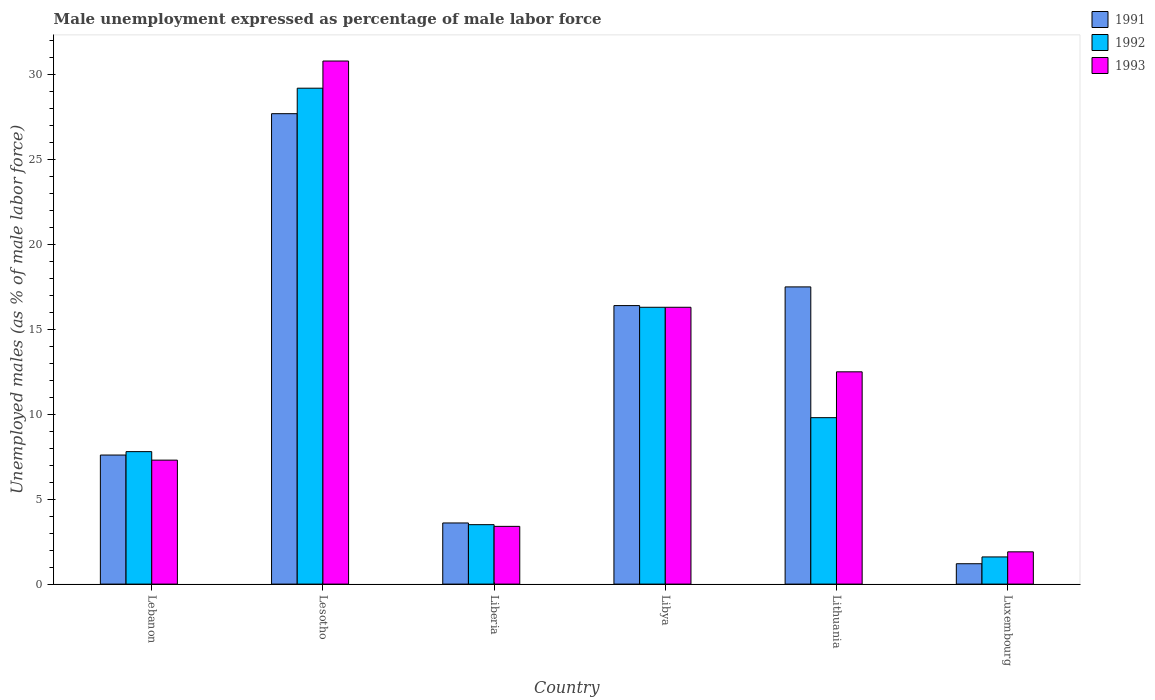How many different coloured bars are there?
Keep it short and to the point. 3. Are the number of bars per tick equal to the number of legend labels?
Ensure brevity in your answer.  Yes. Are the number of bars on each tick of the X-axis equal?
Provide a short and direct response. Yes. What is the label of the 2nd group of bars from the left?
Keep it short and to the point. Lesotho. In how many cases, is the number of bars for a given country not equal to the number of legend labels?
Offer a terse response. 0. What is the unemployment in males in in 1991 in Lebanon?
Your response must be concise. 7.6. Across all countries, what is the maximum unemployment in males in in 1993?
Offer a very short reply. 30.8. Across all countries, what is the minimum unemployment in males in in 1991?
Ensure brevity in your answer.  1.2. In which country was the unemployment in males in in 1993 maximum?
Your response must be concise. Lesotho. In which country was the unemployment in males in in 1992 minimum?
Provide a short and direct response. Luxembourg. What is the total unemployment in males in in 1992 in the graph?
Give a very brief answer. 68.2. What is the difference between the unemployment in males in in 1992 in Lithuania and that in Luxembourg?
Ensure brevity in your answer.  8.2. What is the difference between the unemployment in males in in 1991 in Luxembourg and the unemployment in males in in 1992 in Lebanon?
Offer a terse response. -6.6. What is the average unemployment in males in in 1992 per country?
Your response must be concise. 11.37. What is the difference between the unemployment in males in of/in 1993 and unemployment in males in of/in 1991 in Lebanon?
Your response must be concise. -0.3. In how many countries, is the unemployment in males in in 1992 greater than 24 %?
Your answer should be compact. 1. What is the ratio of the unemployment in males in in 1991 in Lesotho to that in Luxembourg?
Offer a very short reply. 23.08. Is the unemployment in males in in 1993 in Lesotho less than that in Liberia?
Your answer should be compact. No. What is the difference between the highest and the second highest unemployment in males in in 1992?
Offer a terse response. 6.5. What is the difference between the highest and the lowest unemployment in males in in 1991?
Give a very brief answer. 26.5. In how many countries, is the unemployment in males in in 1991 greater than the average unemployment in males in in 1991 taken over all countries?
Offer a very short reply. 3. What is the difference between two consecutive major ticks on the Y-axis?
Offer a very short reply. 5. Are the values on the major ticks of Y-axis written in scientific E-notation?
Your response must be concise. No. Does the graph contain any zero values?
Offer a terse response. No. Does the graph contain grids?
Give a very brief answer. No. How many legend labels are there?
Provide a short and direct response. 3. What is the title of the graph?
Offer a very short reply. Male unemployment expressed as percentage of male labor force. What is the label or title of the Y-axis?
Your response must be concise. Unemployed males (as % of male labor force). What is the Unemployed males (as % of male labor force) of 1991 in Lebanon?
Offer a terse response. 7.6. What is the Unemployed males (as % of male labor force) of 1992 in Lebanon?
Offer a very short reply. 7.8. What is the Unemployed males (as % of male labor force) in 1993 in Lebanon?
Your response must be concise. 7.3. What is the Unemployed males (as % of male labor force) of 1991 in Lesotho?
Make the answer very short. 27.7. What is the Unemployed males (as % of male labor force) of 1992 in Lesotho?
Offer a very short reply. 29.2. What is the Unemployed males (as % of male labor force) in 1993 in Lesotho?
Your answer should be very brief. 30.8. What is the Unemployed males (as % of male labor force) of 1991 in Liberia?
Your answer should be very brief. 3.6. What is the Unemployed males (as % of male labor force) of 1993 in Liberia?
Ensure brevity in your answer.  3.4. What is the Unemployed males (as % of male labor force) in 1991 in Libya?
Your answer should be very brief. 16.4. What is the Unemployed males (as % of male labor force) in 1992 in Libya?
Your answer should be very brief. 16.3. What is the Unemployed males (as % of male labor force) in 1993 in Libya?
Provide a succinct answer. 16.3. What is the Unemployed males (as % of male labor force) of 1992 in Lithuania?
Your answer should be compact. 9.8. What is the Unemployed males (as % of male labor force) of 1991 in Luxembourg?
Keep it short and to the point. 1.2. What is the Unemployed males (as % of male labor force) in 1992 in Luxembourg?
Your response must be concise. 1.6. What is the Unemployed males (as % of male labor force) of 1993 in Luxembourg?
Ensure brevity in your answer.  1.9. Across all countries, what is the maximum Unemployed males (as % of male labor force) of 1991?
Your answer should be compact. 27.7. Across all countries, what is the maximum Unemployed males (as % of male labor force) in 1992?
Provide a succinct answer. 29.2. Across all countries, what is the maximum Unemployed males (as % of male labor force) of 1993?
Keep it short and to the point. 30.8. Across all countries, what is the minimum Unemployed males (as % of male labor force) in 1991?
Your response must be concise. 1.2. Across all countries, what is the minimum Unemployed males (as % of male labor force) of 1992?
Ensure brevity in your answer.  1.6. Across all countries, what is the minimum Unemployed males (as % of male labor force) in 1993?
Your answer should be very brief. 1.9. What is the total Unemployed males (as % of male labor force) in 1992 in the graph?
Make the answer very short. 68.2. What is the total Unemployed males (as % of male labor force) of 1993 in the graph?
Your answer should be compact. 72.2. What is the difference between the Unemployed males (as % of male labor force) of 1991 in Lebanon and that in Lesotho?
Make the answer very short. -20.1. What is the difference between the Unemployed males (as % of male labor force) of 1992 in Lebanon and that in Lesotho?
Make the answer very short. -21.4. What is the difference between the Unemployed males (as % of male labor force) in 1993 in Lebanon and that in Lesotho?
Your answer should be very brief. -23.5. What is the difference between the Unemployed males (as % of male labor force) of 1991 in Lebanon and that in Liberia?
Your answer should be compact. 4. What is the difference between the Unemployed males (as % of male labor force) of 1992 in Lebanon and that in Liberia?
Your response must be concise. 4.3. What is the difference between the Unemployed males (as % of male labor force) of 1993 in Lebanon and that in Liberia?
Offer a very short reply. 3.9. What is the difference between the Unemployed males (as % of male labor force) in 1993 in Lebanon and that in Libya?
Provide a short and direct response. -9. What is the difference between the Unemployed males (as % of male labor force) in 1991 in Lebanon and that in Lithuania?
Your answer should be compact. -9.9. What is the difference between the Unemployed males (as % of male labor force) in 1992 in Lebanon and that in Lithuania?
Your response must be concise. -2. What is the difference between the Unemployed males (as % of male labor force) in 1993 in Lebanon and that in Lithuania?
Your answer should be compact. -5.2. What is the difference between the Unemployed males (as % of male labor force) of 1991 in Lebanon and that in Luxembourg?
Give a very brief answer. 6.4. What is the difference between the Unemployed males (as % of male labor force) in 1991 in Lesotho and that in Liberia?
Give a very brief answer. 24.1. What is the difference between the Unemployed males (as % of male labor force) of 1992 in Lesotho and that in Liberia?
Make the answer very short. 25.7. What is the difference between the Unemployed males (as % of male labor force) in 1993 in Lesotho and that in Liberia?
Give a very brief answer. 27.4. What is the difference between the Unemployed males (as % of male labor force) in 1991 in Lesotho and that in Libya?
Your response must be concise. 11.3. What is the difference between the Unemployed males (as % of male labor force) in 1992 in Lesotho and that in Lithuania?
Keep it short and to the point. 19.4. What is the difference between the Unemployed males (as % of male labor force) of 1992 in Lesotho and that in Luxembourg?
Make the answer very short. 27.6. What is the difference between the Unemployed males (as % of male labor force) of 1993 in Lesotho and that in Luxembourg?
Your answer should be very brief. 28.9. What is the difference between the Unemployed males (as % of male labor force) in 1991 in Liberia and that in Libya?
Your answer should be very brief. -12.8. What is the difference between the Unemployed males (as % of male labor force) of 1993 in Liberia and that in Libya?
Keep it short and to the point. -12.9. What is the difference between the Unemployed males (as % of male labor force) of 1991 in Liberia and that in Lithuania?
Your answer should be compact. -13.9. What is the difference between the Unemployed males (as % of male labor force) in 1992 in Liberia and that in Luxembourg?
Offer a very short reply. 1.9. What is the difference between the Unemployed males (as % of male labor force) of 1993 in Liberia and that in Luxembourg?
Provide a short and direct response. 1.5. What is the difference between the Unemployed males (as % of male labor force) of 1991 in Libya and that in Lithuania?
Make the answer very short. -1.1. What is the difference between the Unemployed males (as % of male labor force) in 1992 in Libya and that in Lithuania?
Provide a succinct answer. 6.5. What is the difference between the Unemployed males (as % of male labor force) of 1993 in Libya and that in Lithuania?
Ensure brevity in your answer.  3.8. What is the difference between the Unemployed males (as % of male labor force) of 1991 in Libya and that in Luxembourg?
Ensure brevity in your answer.  15.2. What is the difference between the Unemployed males (as % of male labor force) of 1993 in Libya and that in Luxembourg?
Offer a terse response. 14.4. What is the difference between the Unemployed males (as % of male labor force) of 1991 in Lithuania and that in Luxembourg?
Ensure brevity in your answer.  16.3. What is the difference between the Unemployed males (as % of male labor force) of 1993 in Lithuania and that in Luxembourg?
Your answer should be compact. 10.6. What is the difference between the Unemployed males (as % of male labor force) of 1991 in Lebanon and the Unemployed males (as % of male labor force) of 1992 in Lesotho?
Your response must be concise. -21.6. What is the difference between the Unemployed males (as % of male labor force) of 1991 in Lebanon and the Unemployed males (as % of male labor force) of 1993 in Lesotho?
Give a very brief answer. -23.2. What is the difference between the Unemployed males (as % of male labor force) in 1992 in Lebanon and the Unemployed males (as % of male labor force) in 1993 in Lesotho?
Offer a very short reply. -23. What is the difference between the Unemployed males (as % of male labor force) of 1991 in Lebanon and the Unemployed males (as % of male labor force) of 1993 in Liberia?
Make the answer very short. 4.2. What is the difference between the Unemployed males (as % of male labor force) of 1992 in Lebanon and the Unemployed males (as % of male labor force) of 1993 in Libya?
Your answer should be compact. -8.5. What is the difference between the Unemployed males (as % of male labor force) in 1991 in Lebanon and the Unemployed males (as % of male labor force) in 1993 in Lithuania?
Make the answer very short. -4.9. What is the difference between the Unemployed males (as % of male labor force) in 1992 in Lebanon and the Unemployed males (as % of male labor force) in 1993 in Lithuania?
Offer a terse response. -4.7. What is the difference between the Unemployed males (as % of male labor force) in 1991 in Lebanon and the Unemployed males (as % of male labor force) in 1993 in Luxembourg?
Provide a succinct answer. 5.7. What is the difference between the Unemployed males (as % of male labor force) in 1991 in Lesotho and the Unemployed males (as % of male labor force) in 1992 in Liberia?
Your response must be concise. 24.2. What is the difference between the Unemployed males (as % of male labor force) of 1991 in Lesotho and the Unemployed males (as % of male labor force) of 1993 in Liberia?
Provide a succinct answer. 24.3. What is the difference between the Unemployed males (as % of male labor force) in 1992 in Lesotho and the Unemployed males (as % of male labor force) in 1993 in Liberia?
Keep it short and to the point. 25.8. What is the difference between the Unemployed males (as % of male labor force) in 1991 in Lesotho and the Unemployed males (as % of male labor force) in 1993 in Libya?
Make the answer very short. 11.4. What is the difference between the Unemployed males (as % of male labor force) in 1992 in Lesotho and the Unemployed males (as % of male labor force) in 1993 in Libya?
Offer a very short reply. 12.9. What is the difference between the Unemployed males (as % of male labor force) of 1991 in Lesotho and the Unemployed males (as % of male labor force) of 1992 in Lithuania?
Make the answer very short. 17.9. What is the difference between the Unemployed males (as % of male labor force) of 1991 in Lesotho and the Unemployed males (as % of male labor force) of 1993 in Lithuania?
Provide a short and direct response. 15.2. What is the difference between the Unemployed males (as % of male labor force) of 1992 in Lesotho and the Unemployed males (as % of male labor force) of 1993 in Lithuania?
Make the answer very short. 16.7. What is the difference between the Unemployed males (as % of male labor force) of 1991 in Lesotho and the Unemployed males (as % of male labor force) of 1992 in Luxembourg?
Offer a terse response. 26.1. What is the difference between the Unemployed males (as % of male labor force) of 1991 in Lesotho and the Unemployed males (as % of male labor force) of 1993 in Luxembourg?
Offer a very short reply. 25.8. What is the difference between the Unemployed males (as % of male labor force) of 1992 in Lesotho and the Unemployed males (as % of male labor force) of 1993 in Luxembourg?
Ensure brevity in your answer.  27.3. What is the difference between the Unemployed males (as % of male labor force) in 1992 in Liberia and the Unemployed males (as % of male labor force) in 1993 in Libya?
Your answer should be compact. -12.8. What is the difference between the Unemployed males (as % of male labor force) in 1991 in Liberia and the Unemployed males (as % of male labor force) in 1992 in Lithuania?
Provide a succinct answer. -6.2. What is the difference between the Unemployed males (as % of male labor force) of 1991 in Liberia and the Unemployed males (as % of male labor force) of 1993 in Luxembourg?
Make the answer very short. 1.7. What is the difference between the Unemployed males (as % of male labor force) in 1992 in Liberia and the Unemployed males (as % of male labor force) in 1993 in Luxembourg?
Your answer should be compact. 1.6. What is the difference between the Unemployed males (as % of male labor force) in 1991 in Libya and the Unemployed males (as % of male labor force) in 1992 in Lithuania?
Give a very brief answer. 6.6. What is the difference between the Unemployed males (as % of male labor force) in 1991 in Libya and the Unemployed males (as % of male labor force) in 1992 in Luxembourg?
Ensure brevity in your answer.  14.8. What is the difference between the Unemployed males (as % of male labor force) of 1992 in Libya and the Unemployed males (as % of male labor force) of 1993 in Luxembourg?
Your response must be concise. 14.4. What is the difference between the Unemployed males (as % of male labor force) of 1991 in Lithuania and the Unemployed males (as % of male labor force) of 1992 in Luxembourg?
Provide a short and direct response. 15.9. What is the average Unemployed males (as % of male labor force) of 1991 per country?
Your answer should be compact. 12.33. What is the average Unemployed males (as % of male labor force) of 1992 per country?
Keep it short and to the point. 11.37. What is the average Unemployed males (as % of male labor force) in 1993 per country?
Offer a terse response. 12.03. What is the difference between the Unemployed males (as % of male labor force) in 1991 and Unemployed males (as % of male labor force) in 1992 in Lebanon?
Make the answer very short. -0.2. What is the difference between the Unemployed males (as % of male labor force) in 1991 and Unemployed males (as % of male labor force) in 1993 in Lebanon?
Make the answer very short. 0.3. What is the difference between the Unemployed males (as % of male labor force) of 1991 and Unemployed males (as % of male labor force) of 1993 in Lesotho?
Your answer should be compact. -3.1. What is the difference between the Unemployed males (as % of male labor force) of 1991 and Unemployed males (as % of male labor force) of 1992 in Liberia?
Your answer should be compact. 0.1. What is the difference between the Unemployed males (as % of male labor force) of 1991 and Unemployed males (as % of male labor force) of 1993 in Libya?
Offer a terse response. 0.1. What is the difference between the Unemployed males (as % of male labor force) in 1992 and Unemployed males (as % of male labor force) in 1993 in Libya?
Offer a terse response. 0. What is the difference between the Unemployed males (as % of male labor force) in 1991 and Unemployed males (as % of male labor force) in 1992 in Lithuania?
Your answer should be compact. 7.7. What is the difference between the Unemployed males (as % of male labor force) of 1991 and Unemployed males (as % of male labor force) of 1993 in Lithuania?
Keep it short and to the point. 5. What is the difference between the Unemployed males (as % of male labor force) of 1991 and Unemployed males (as % of male labor force) of 1992 in Luxembourg?
Your answer should be very brief. -0.4. What is the difference between the Unemployed males (as % of male labor force) in 1991 and Unemployed males (as % of male labor force) in 1993 in Luxembourg?
Your response must be concise. -0.7. What is the difference between the Unemployed males (as % of male labor force) of 1992 and Unemployed males (as % of male labor force) of 1993 in Luxembourg?
Make the answer very short. -0.3. What is the ratio of the Unemployed males (as % of male labor force) in 1991 in Lebanon to that in Lesotho?
Provide a succinct answer. 0.27. What is the ratio of the Unemployed males (as % of male labor force) in 1992 in Lebanon to that in Lesotho?
Provide a succinct answer. 0.27. What is the ratio of the Unemployed males (as % of male labor force) in 1993 in Lebanon to that in Lesotho?
Make the answer very short. 0.24. What is the ratio of the Unemployed males (as % of male labor force) of 1991 in Lebanon to that in Liberia?
Give a very brief answer. 2.11. What is the ratio of the Unemployed males (as % of male labor force) of 1992 in Lebanon to that in Liberia?
Offer a terse response. 2.23. What is the ratio of the Unemployed males (as % of male labor force) of 1993 in Lebanon to that in Liberia?
Keep it short and to the point. 2.15. What is the ratio of the Unemployed males (as % of male labor force) of 1991 in Lebanon to that in Libya?
Keep it short and to the point. 0.46. What is the ratio of the Unemployed males (as % of male labor force) of 1992 in Lebanon to that in Libya?
Keep it short and to the point. 0.48. What is the ratio of the Unemployed males (as % of male labor force) of 1993 in Lebanon to that in Libya?
Your answer should be very brief. 0.45. What is the ratio of the Unemployed males (as % of male labor force) of 1991 in Lebanon to that in Lithuania?
Give a very brief answer. 0.43. What is the ratio of the Unemployed males (as % of male labor force) in 1992 in Lebanon to that in Lithuania?
Ensure brevity in your answer.  0.8. What is the ratio of the Unemployed males (as % of male labor force) of 1993 in Lebanon to that in Lithuania?
Your answer should be compact. 0.58. What is the ratio of the Unemployed males (as % of male labor force) in 1991 in Lebanon to that in Luxembourg?
Keep it short and to the point. 6.33. What is the ratio of the Unemployed males (as % of male labor force) of 1992 in Lebanon to that in Luxembourg?
Provide a succinct answer. 4.88. What is the ratio of the Unemployed males (as % of male labor force) in 1993 in Lebanon to that in Luxembourg?
Provide a short and direct response. 3.84. What is the ratio of the Unemployed males (as % of male labor force) in 1991 in Lesotho to that in Liberia?
Your answer should be very brief. 7.69. What is the ratio of the Unemployed males (as % of male labor force) of 1992 in Lesotho to that in Liberia?
Keep it short and to the point. 8.34. What is the ratio of the Unemployed males (as % of male labor force) of 1993 in Lesotho to that in Liberia?
Ensure brevity in your answer.  9.06. What is the ratio of the Unemployed males (as % of male labor force) of 1991 in Lesotho to that in Libya?
Your response must be concise. 1.69. What is the ratio of the Unemployed males (as % of male labor force) in 1992 in Lesotho to that in Libya?
Provide a succinct answer. 1.79. What is the ratio of the Unemployed males (as % of male labor force) of 1993 in Lesotho to that in Libya?
Your answer should be very brief. 1.89. What is the ratio of the Unemployed males (as % of male labor force) in 1991 in Lesotho to that in Lithuania?
Offer a terse response. 1.58. What is the ratio of the Unemployed males (as % of male labor force) in 1992 in Lesotho to that in Lithuania?
Provide a succinct answer. 2.98. What is the ratio of the Unemployed males (as % of male labor force) in 1993 in Lesotho to that in Lithuania?
Your answer should be very brief. 2.46. What is the ratio of the Unemployed males (as % of male labor force) in 1991 in Lesotho to that in Luxembourg?
Offer a very short reply. 23.08. What is the ratio of the Unemployed males (as % of male labor force) in 1992 in Lesotho to that in Luxembourg?
Your answer should be very brief. 18.25. What is the ratio of the Unemployed males (as % of male labor force) in 1993 in Lesotho to that in Luxembourg?
Make the answer very short. 16.21. What is the ratio of the Unemployed males (as % of male labor force) of 1991 in Liberia to that in Libya?
Give a very brief answer. 0.22. What is the ratio of the Unemployed males (as % of male labor force) of 1992 in Liberia to that in Libya?
Offer a terse response. 0.21. What is the ratio of the Unemployed males (as % of male labor force) in 1993 in Liberia to that in Libya?
Ensure brevity in your answer.  0.21. What is the ratio of the Unemployed males (as % of male labor force) of 1991 in Liberia to that in Lithuania?
Offer a terse response. 0.21. What is the ratio of the Unemployed males (as % of male labor force) of 1992 in Liberia to that in Lithuania?
Provide a succinct answer. 0.36. What is the ratio of the Unemployed males (as % of male labor force) of 1993 in Liberia to that in Lithuania?
Keep it short and to the point. 0.27. What is the ratio of the Unemployed males (as % of male labor force) of 1992 in Liberia to that in Luxembourg?
Ensure brevity in your answer.  2.19. What is the ratio of the Unemployed males (as % of male labor force) of 1993 in Liberia to that in Luxembourg?
Provide a succinct answer. 1.79. What is the ratio of the Unemployed males (as % of male labor force) in 1991 in Libya to that in Lithuania?
Give a very brief answer. 0.94. What is the ratio of the Unemployed males (as % of male labor force) of 1992 in Libya to that in Lithuania?
Give a very brief answer. 1.66. What is the ratio of the Unemployed males (as % of male labor force) in 1993 in Libya to that in Lithuania?
Ensure brevity in your answer.  1.3. What is the ratio of the Unemployed males (as % of male labor force) in 1991 in Libya to that in Luxembourg?
Offer a very short reply. 13.67. What is the ratio of the Unemployed males (as % of male labor force) of 1992 in Libya to that in Luxembourg?
Make the answer very short. 10.19. What is the ratio of the Unemployed males (as % of male labor force) in 1993 in Libya to that in Luxembourg?
Your answer should be compact. 8.58. What is the ratio of the Unemployed males (as % of male labor force) in 1991 in Lithuania to that in Luxembourg?
Offer a very short reply. 14.58. What is the ratio of the Unemployed males (as % of male labor force) of 1992 in Lithuania to that in Luxembourg?
Your answer should be very brief. 6.12. What is the ratio of the Unemployed males (as % of male labor force) of 1993 in Lithuania to that in Luxembourg?
Provide a succinct answer. 6.58. What is the difference between the highest and the second highest Unemployed males (as % of male labor force) of 1991?
Your response must be concise. 10.2. What is the difference between the highest and the second highest Unemployed males (as % of male labor force) in 1993?
Make the answer very short. 14.5. What is the difference between the highest and the lowest Unemployed males (as % of male labor force) in 1991?
Make the answer very short. 26.5. What is the difference between the highest and the lowest Unemployed males (as % of male labor force) of 1992?
Your answer should be very brief. 27.6. What is the difference between the highest and the lowest Unemployed males (as % of male labor force) of 1993?
Give a very brief answer. 28.9. 